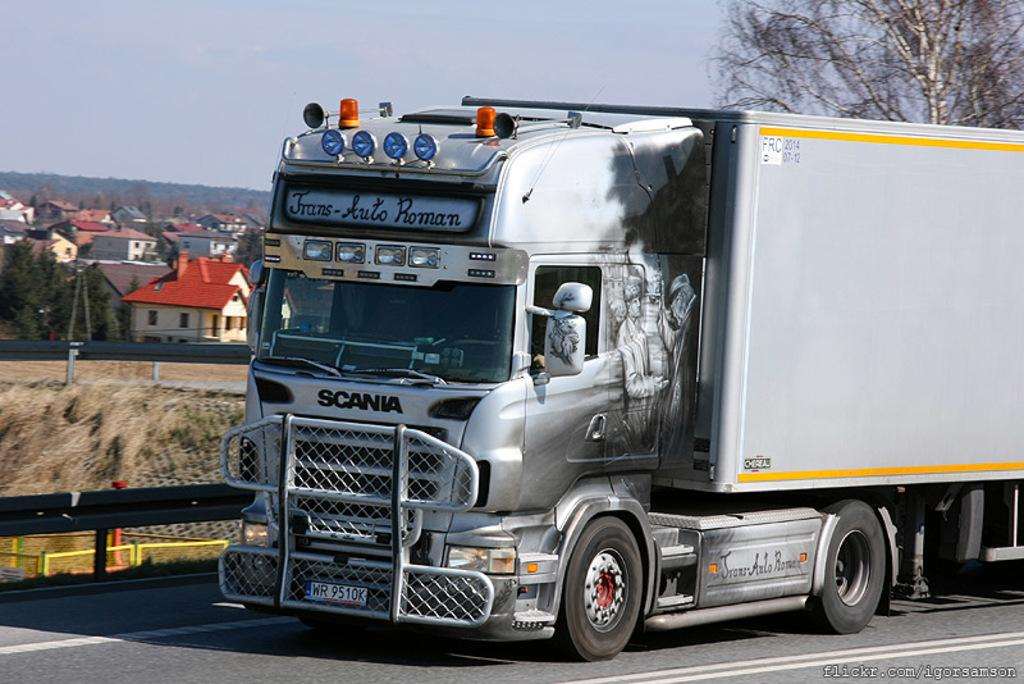What is the main subject of the image? There is a vehicle on the road in the image. What can be seen behind the vehicle? There is a tree behind the vehicle. What is present on the left side of the image? There are many trees and buildings on the left side of the image. What is visible at the top of the image? The sky is visible at the top of the image. How many lizards can be seen on the vehicle in the image? There are no lizards present on the vehicle or in the image. What type of pet is sitting next to the driver in the image? There is no pet visible in the image. 